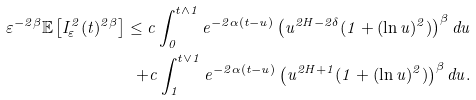Convert formula to latex. <formula><loc_0><loc_0><loc_500><loc_500>\varepsilon ^ { - 2 \beta } \mathbb { E } \left [ I ^ { 2 } _ { \varepsilon } ( t ) ^ { 2 \beta } \right ] \leq c \int _ { 0 } ^ { t \wedge 1 } { e ^ { - 2 \alpha ( t - u ) } \left ( u ^ { 2 H - 2 \delta } ( 1 + ( \ln u ) ^ { 2 } ) \right ) ^ { \beta } d u } \\ + c \int _ { 1 } ^ { t \vee 1 } { e ^ { - 2 \alpha ( t - u ) } \left ( u ^ { 2 H + 1 } ( 1 + ( \ln u ) ^ { 2 } ) \right ) ^ { \beta } d u } .</formula> 